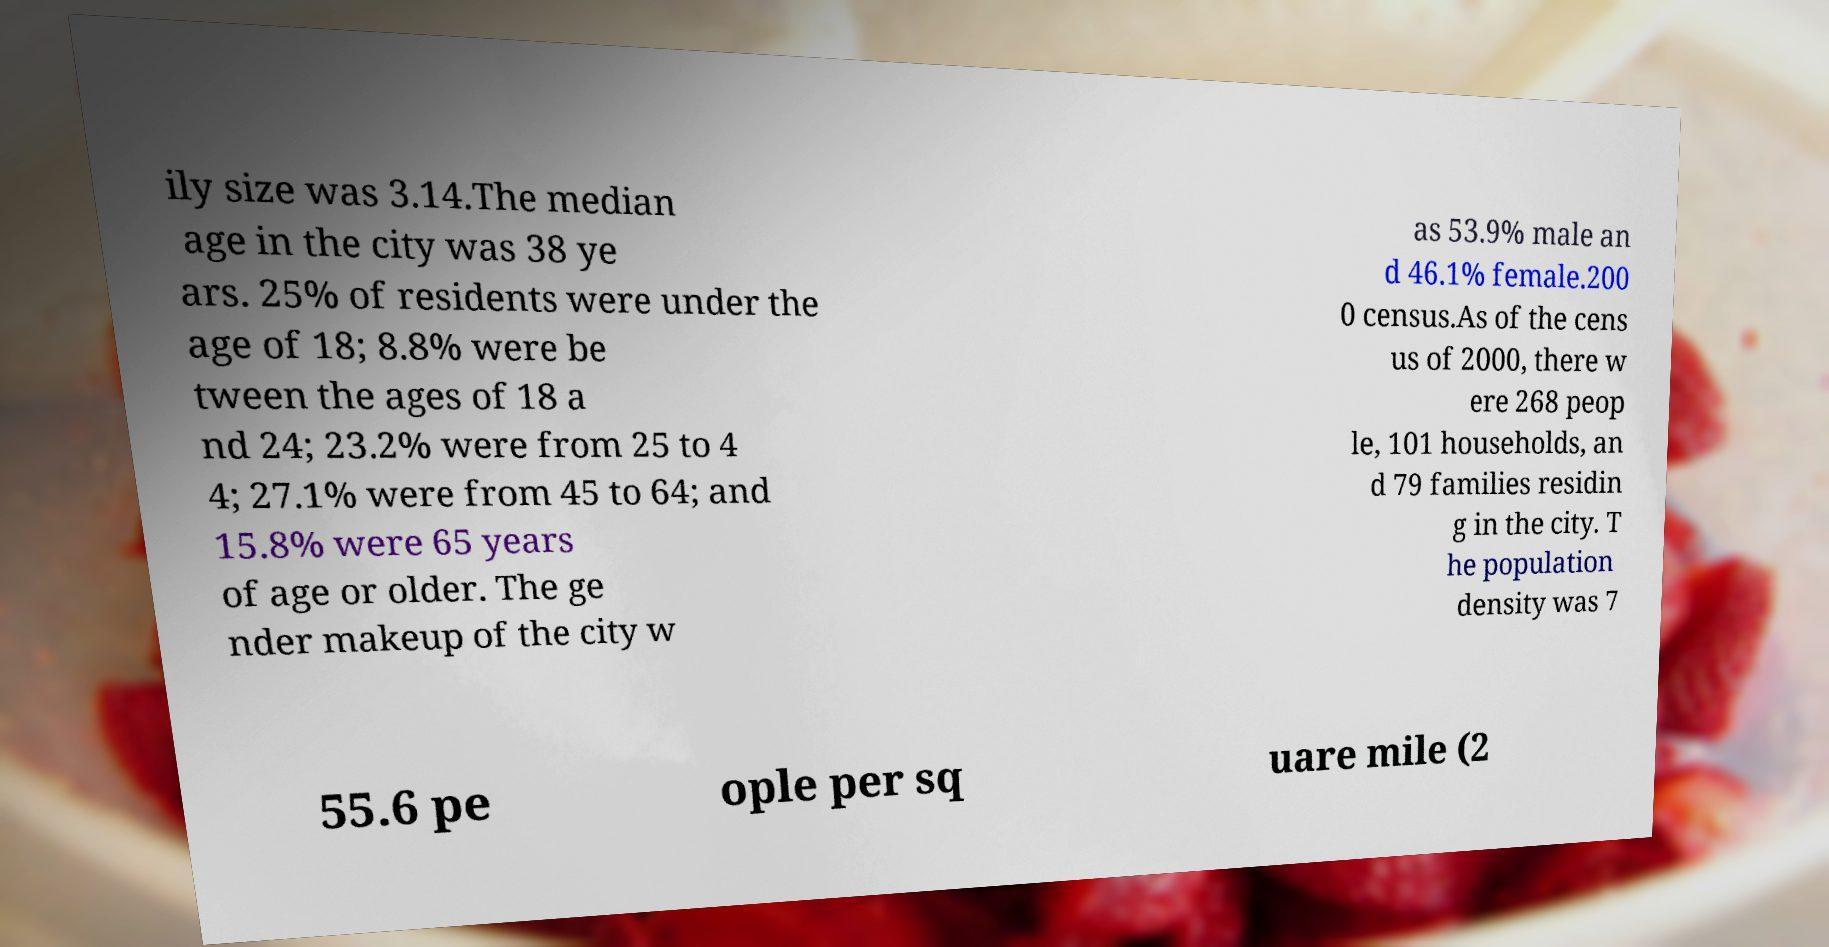Can you accurately transcribe the text from the provided image for me? ily size was 3.14.The median age in the city was 38 ye ars. 25% of residents were under the age of 18; 8.8% were be tween the ages of 18 a nd 24; 23.2% were from 25 to 4 4; 27.1% were from 45 to 64; and 15.8% were 65 years of age or older. The ge nder makeup of the city w as 53.9% male an d 46.1% female.200 0 census.As of the cens us of 2000, there w ere 268 peop le, 101 households, an d 79 families residin g in the city. T he population density was 7 55.6 pe ople per sq uare mile (2 